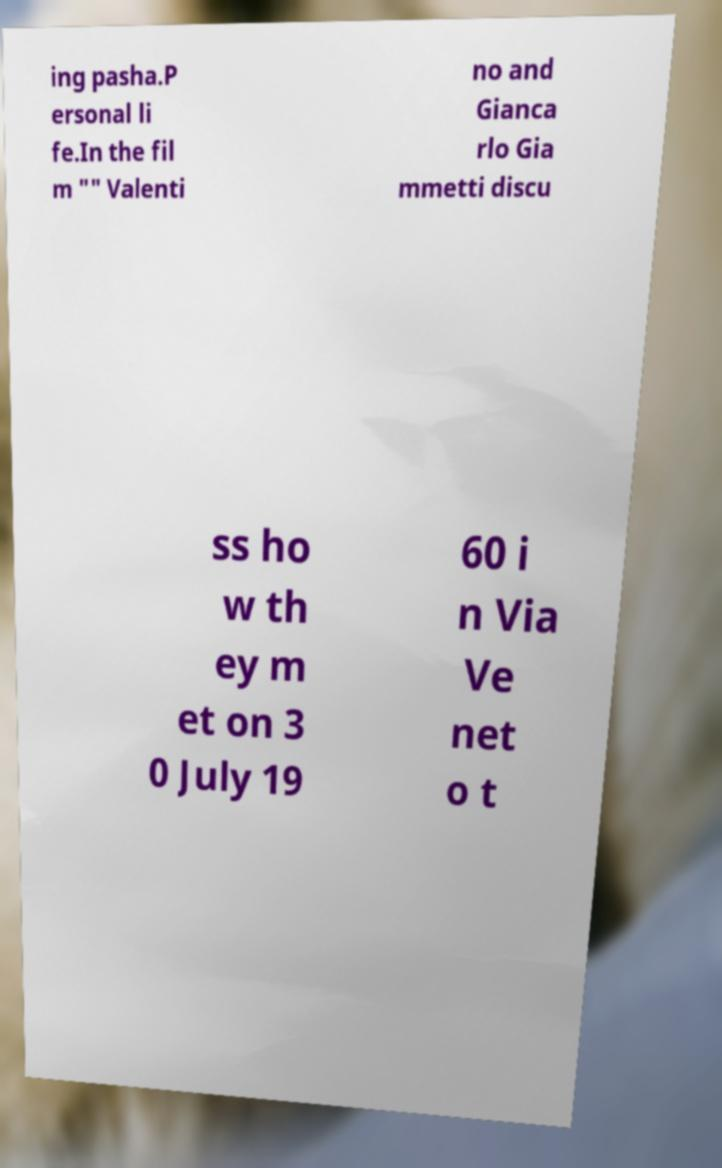Can you accurately transcribe the text from the provided image for me? ing pasha.P ersonal li fe.In the fil m "" Valenti no and Gianca rlo Gia mmetti discu ss ho w th ey m et on 3 0 July 19 60 i n Via Ve net o t 